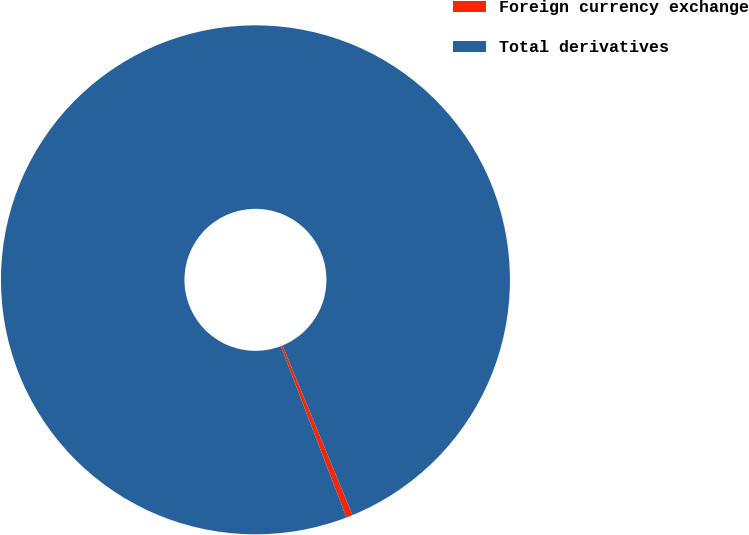Convert chart. <chart><loc_0><loc_0><loc_500><loc_500><pie_chart><fcel>Foreign currency exchange<fcel>Total derivatives<nl><fcel>0.41%<fcel>99.59%<nl></chart> 